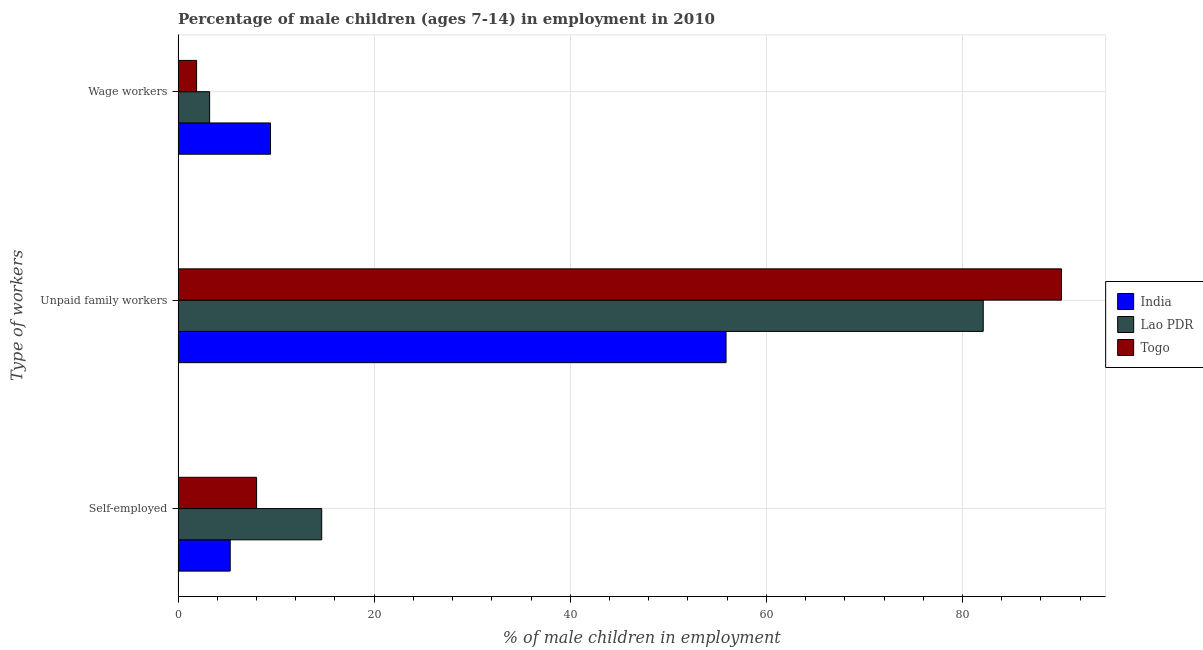How many different coloured bars are there?
Your response must be concise. 3. Are the number of bars per tick equal to the number of legend labels?
Provide a succinct answer. Yes. What is the label of the 1st group of bars from the top?
Your answer should be very brief. Wage workers. What is the percentage of children employed as wage workers in Togo?
Provide a short and direct response. 1.89. Across all countries, what is the maximum percentage of self employed children?
Provide a succinct answer. 14.65. Across all countries, what is the minimum percentage of children employed as wage workers?
Provide a short and direct response. 1.89. In which country was the percentage of self employed children maximum?
Provide a short and direct response. Lao PDR. In which country was the percentage of children employed as unpaid family workers minimum?
Your answer should be compact. India. What is the total percentage of self employed children in the graph?
Provide a short and direct response. 27.98. What is the difference between the percentage of children employed as wage workers in India and that in Togo?
Provide a short and direct response. 7.54. What is the difference between the percentage of children employed as unpaid family workers in Togo and the percentage of self employed children in Lao PDR?
Provide a succinct answer. 75.45. What is the average percentage of children employed as wage workers per country?
Keep it short and to the point. 4.85. What is the difference between the percentage of self employed children and percentage of children employed as wage workers in India?
Your response must be concise. -4.11. What is the ratio of the percentage of children employed as wage workers in India to that in Togo?
Offer a very short reply. 4.99. Is the difference between the percentage of children employed as wage workers in India and Lao PDR greater than the difference between the percentage of self employed children in India and Lao PDR?
Keep it short and to the point. Yes. What is the difference between the highest and the second highest percentage of children employed as unpaid family workers?
Your response must be concise. 7.98. What is the difference between the highest and the lowest percentage of children employed as wage workers?
Your answer should be very brief. 7.54. In how many countries, is the percentage of children employed as unpaid family workers greater than the average percentage of children employed as unpaid family workers taken over all countries?
Offer a terse response. 2. Is the sum of the percentage of children employed as unpaid family workers in India and Togo greater than the maximum percentage of self employed children across all countries?
Ensure brevity in your answer.  Yes. What does the 2nd bar from the top in Self-employed represents?
Make the answer very short. Lao PDR. What does the 2nd bar from the bottom in Unpaid family workers represents?
Your answer should be very brief. Lao PDR. Is it the case that in every country, the sum of the percentage of self employed children and percentage of children employed as unpaid family workers is greater than the percentage of children employed as wage workers?
Offer a terse response. Yes. How many countries are there in the graph?
Your answer should be compact. 3. Does the graph contain any zero values?
Your response must be concise. No. Does the graph contain grids?
Give a very brief answer. Yes. Where does the legend appear in the graph?
Keep it short and to the point. Center right. How are the legend labels stacked?
Your answer should be very brief. Vertical. What is the title of the graph?
Provide a succinct answer. Percentage of male children (ages 7-14) in employment in 2010. Does "Lao PDR" appear as one of the legend labels in the graph?
Provide a succinct answer. Yes. What is the label or title of the X-axis?
Make the answer very short. % of male children in employment. What is the label or title of the Y-axis?
Provide a short and direct response. Type of workers. What is the % of male children in employment in India in Self-employed?
Give a very brief answer. 5.32. What is the % of male children in employment in Lao PDR in Self-employed?
Keep it short and to the point. 14.65. What is the % of male children in employment of Togo in Self-employed?
Ensure brevity in your answer.  8.01. What is the % of male children in employment in India in Unpaid family workers?
Provide a short and direct response. 55.89. What is the % of male children in employment of Lao PDR in Unpaid family workers?
Offer a very short reply. 82.12. What is the % of male children in employment of Togo in Unpaid family workers?
Keep it short and to the point. 90.1. What is the % of male children in employment of India in Wage workers?
Give a very brief answer. 9.43. What is the % of male children in employment in Lao PDR in Wage workers?
Make the answer very short. 3.22. What is the % of male children in employment in Togo in Wage workers?
Your answer should be compact. 1.89. Across all Type of workers, what is the maximum % of male children in employment in India?
Keep it short and to the point. 55.89. Across all Type of workers, what is the maximum % of male children in employment in Lao PDR?
Give a very brief answer. 82.12. Across all Type of workers, what is the maximum % of male children in employment in Togo?
Offer a very short reply. 90.1. Across all Type of workers, what is the minimum % of male children in employment of India?
Provide a succinct answer. 5.32. Across all Type of workers, what is the minimum % of male children in employment of Lao PDR?
Your answer should be compact. 3.22. Across all Type of workers, what is the minimum % of male children in employment of Togo?
Provide a short and direct response. 1.89. What is the total % of male children in employment in India in the graph?
Give a very brief answer. 70.64. What is the total % of male children in employment of Lao PDR in the graph?
Provide a succinct answer. 99.99. What is the total % of male children in employment of Togo in the graph?
Offer a very short reply. 100. What is the difference between the % of male children in employment of India in Self-employed and that in Unpaid family workers?
Make the answer very short. -50.57. What is the difference between the % of male children in employment in Lao PDR in Self-employed and that in Unpaid family workers?
Ensure brevity in your answer.  -67.47. What is the difference between the % of male children in employment in Togo in Self-employed and that in Unpaid family workers?
Offer a terse response. -82.09. What is the difference between the % of male children in employment of India in Self-employed and that in Wage workers?
Offer a very short reply. -4.11. What is the difference between the % of male children in employment of Lao PDR in Self-employed and that in Wage workers?
Give a very brief answer. 11.43. What is the difference between the % of male children in employment in Togo in Self-employed and that in Wage workers?
Offer a terse response. 6.12. What is the difference between the % of male children in employment of India in Unpaid family workers and that in Wage workers?
Your answer should be compact. 46.46. What is the difference between the % of male children in employment of Lao PDR in Unpaid family workers and that in Wage workers?
Provide a succinct answer. 78.9. What is the difference between the % of male children in employment in Togo in Unpaid family workers and that in Wage workers?
Offer a very short reply. 88.21. What is the difference between the % of male children in employment of India in Self-employed and the % of male children in employment of Lao PDR in Unpaid family workers?
Provide a succinct answer. -76.8. What is the difference between the % of male children in employment in India in Self-employed and the % of male children in employment in Togo in Unpaid family workers?
Your answer should be very brief. -84.78. What is the difference between the % of male children in employment in Lao PDR in Self-employed and the % of male children in employment in Togo in Unpaid family workers?
Give a very brief answer. -75.45. What is the difference between the % of male children in employment in India in Self-employed and the % of male children in employment in Lao PDR in Wage workers?
Make the answer very short. 2.1. What is the difference between the % of male children in employment in India in Self-employed and the % of male children in employment in Togo in Wage workers?
Ensure brevity in your answer.  3.43. What is the difference between the % of male children in employment in Lao PDR in Self-employed and the % of male children in employment in Togo in Wage workers?
Your answer should be compact. 12.76. What is the difference between the % of male children in employment in India in Unpaid family workers and the % of male children in employment in Lao PDR in Wage workers?
Make the answer very short. 52.67. What is the difference between the % of male children in employment of India in Unpaid family workers and the % of male children in employment of Togo in Wage workers?
Ensure brevity in your answer.  54. What is the difference between the % of male children in employment of Lao PDR in Unpaid family workers and the % of male children in employment of Togo in Wage workers?
Offer a very short reply. 80.23. What is the average % of male children in employment of India per Type of workers?
Make the answer very short. 23.55. What is the average % of male children in employment in Lao PDR per Type of workers?
Provide a succinct answer. 33.33. What is the average % of male children in employment of Togo per Type of workers?
Your answer should be very brief. 33.33. What is the difference between the % of male children in employment in India and % of male children in employment in Lao PDR in Self-employed?
Give a very brief answer. -9.33. What is the difference between the % of male children in employment of India and % of male children in employment of Togo in Self-employed?
Your response must be concise. -2.69. What is the difference between the % of male children in employment of Lao PDR and % of male children in employment of Togo in Self-employed?
Your answer should be compact. 6.64. What is the difference between the % of male children in employment in India and % of male children in employment in Lao PDR in Unpaid family workers?
Make the answer very short. -26.23. What is the difference between the % of male children in employment of India and % of male children in employment of Togo in Unpaid family workers?
Your answer should be very brief. -34.21. What is the difference between the % of male children in employment in Lao PDR and % of male children in employment in Togo in Unpaid family workers?
Offer a terse response. -7.98. What is the difference between the % of male children in employment in India and % of male children in employment in Lao PDR in Wage workers?
Provide a succinct answer. 6.21. What is the difference between the % of male children in employment of India and % of male children in employment of Togo in Wage workers?
Give a very brief answer. 7.54. What is the difference between the % of male children in employment of Lao PDR and % of male children in employment of Togo in Wage workers?
Give a very brief answer. 1.33. What is the ratio of the % of male children in employment in India in Self-employed to that in Unpaid family workers?
Your response must be concise. 0.1. What is the ratio of the % of male children in employment in Lao PDR in Self-employed to that in Unpaid family workers?
Provide a short and direct response. 0.18. What is the ratio of the % of male children in employment in Togo in Self-employed to that in Unpaid family workers?
Give a very brief answer. 0.09. What is the ratio of the % of male children in employment in India in Self-employed to that in Wage workers?
Offer a terse response. 0.56. What is the ratio of the % of male children in employment of Lao PDR in Self-employed to that in Wage workers?
Your answer should be very brief. 4.55. What is the ratio of the % of male children in employment of Togo in Self-employed to that in Wage workers?
Offer a very short reply. 4.24. What is the ratio of the % of male children in employment in India in Unpaid family workers to that in Wage workers?
Ensure brevity in your answer.  5.93. What is the ratio of the % of male children in employment in Lao PDR in Unpaid family workers to that in Wage workers?
Offer a very short reply. 25.5. What is the ratio of the % of male children in employment of Togo in Unpaid family workers to that in Wage workers?
Your response must be concise. 47.67. What is the difference between the highest and the second highest % of male children in employment of India?
Offer a terse response. 46.46. What is the difference between the highest and the second highest % of male children in employment of Lao PDR?
Your answer should be very brief. 67.47. What is the difference between the highest and the second highest % of male children in employment of Togo?
Your response must be concise. 82.09. What is the difference between the highest and the lowest % of male children in employment in India?
Your answer should be compact. 50.57. What is the difference between the highest and the lowest % of male children in employment in Lao PDR?
Give a very brief answer. 78.9. What is the difference between the highest and the lowest % of male children in employment in Togo?
Your response must be concise. 88.21. 